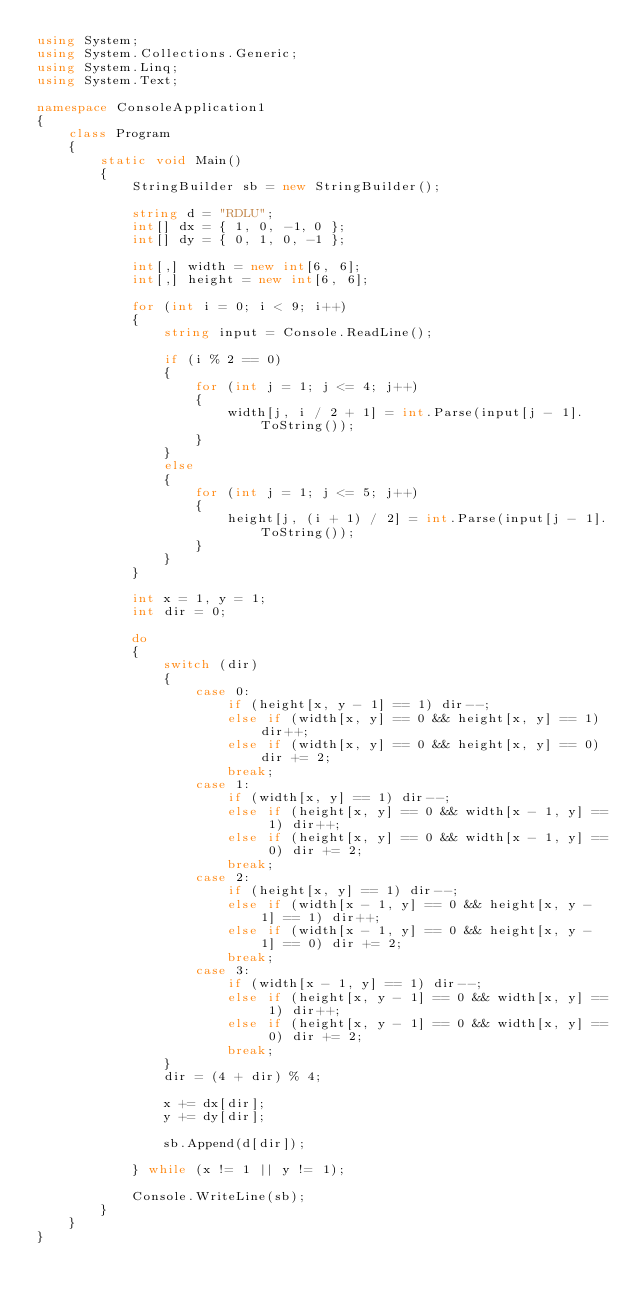Convert code to text. <code><loc_0><loc_0><loc_500><loc_500><_C#_>using System;
using System.Collections.Generic;
using System.Linq;
using System.Text;

namespace ConsoleApplication1
{
    class Program
    {
        static void Main()
        {
            StringBuilder sb = new StringBuilder();

            string d = "RDLU";
            int[] dx = { 1, 0, -1, 0 };
            int[] dy = { 0, 1, 0, -1 };

            int[,] width = new int[6, 6];
            int[,] height = new int[6, 6];

            for (int i = 0; i < 9; i++)
            {
                string input = Console.ReadLine();

                if (i % 2 == 0)
                {
                    for (int j = 1; j <= 4; j++)
                    {
                        width[j, i / 2 + 1] = int.Parse(input[j - 1].ToString());
                    }
                }
                else
                {
                    for (int j = 1; j <= 5; j++)
                    {
                        height[j, (i + 1) / 2] = int.Parse(input[j - 1].ToString());
                    }
                }
            }

            int x = 1, y = 1;
            int dir = 0;

            do
            {
                switch (dir)
                {
                    case 0:
                        if (height[x, y - 1] == 1) dir--;
                        else if (width[x, y] == 0 && height[x, y] == 1) dir++;
                        else if (width[x, y] == 0 && height[x, y] == 0) dir += 2;
                        break;
                    case 1:
                        if (width[x, y] == 1) dir--;
                        else if (height[x, y] == 0 && width[x - 1, y] == 1) dir++;
                        else if (height[x, y] == 0 && width[x - 1, y] == 0) dir += 2;
                        break;
                    case 2:
                        if (height[x, y] == 1) dir--;
                        else if (width[x - 1, y] == 0 && height[x, y - 1] == 1) dir++;
                        else if (width[x - 1, y] == 0 && height[x, y - 1] == 0) dir += 2;
                        break;
                    case 3:
                        if (width[x - 1, y] == 1) dir--;
                        else if (height[x, y - 1] == 0 && width[x, y] == 1) dir++;
                        else if (height[x, y - 1] == 0 && width[x, y] == 0) dir += 2;
                        break;
                }
                dir = (4 + dir) % 4;

                x += dx[dir];
                y += dy[dir];

                sb.Append(d[dir]);

            } while (x != 1 || y != 1);

            Console.WriteLine(sb);
        }
    }
}</code> 